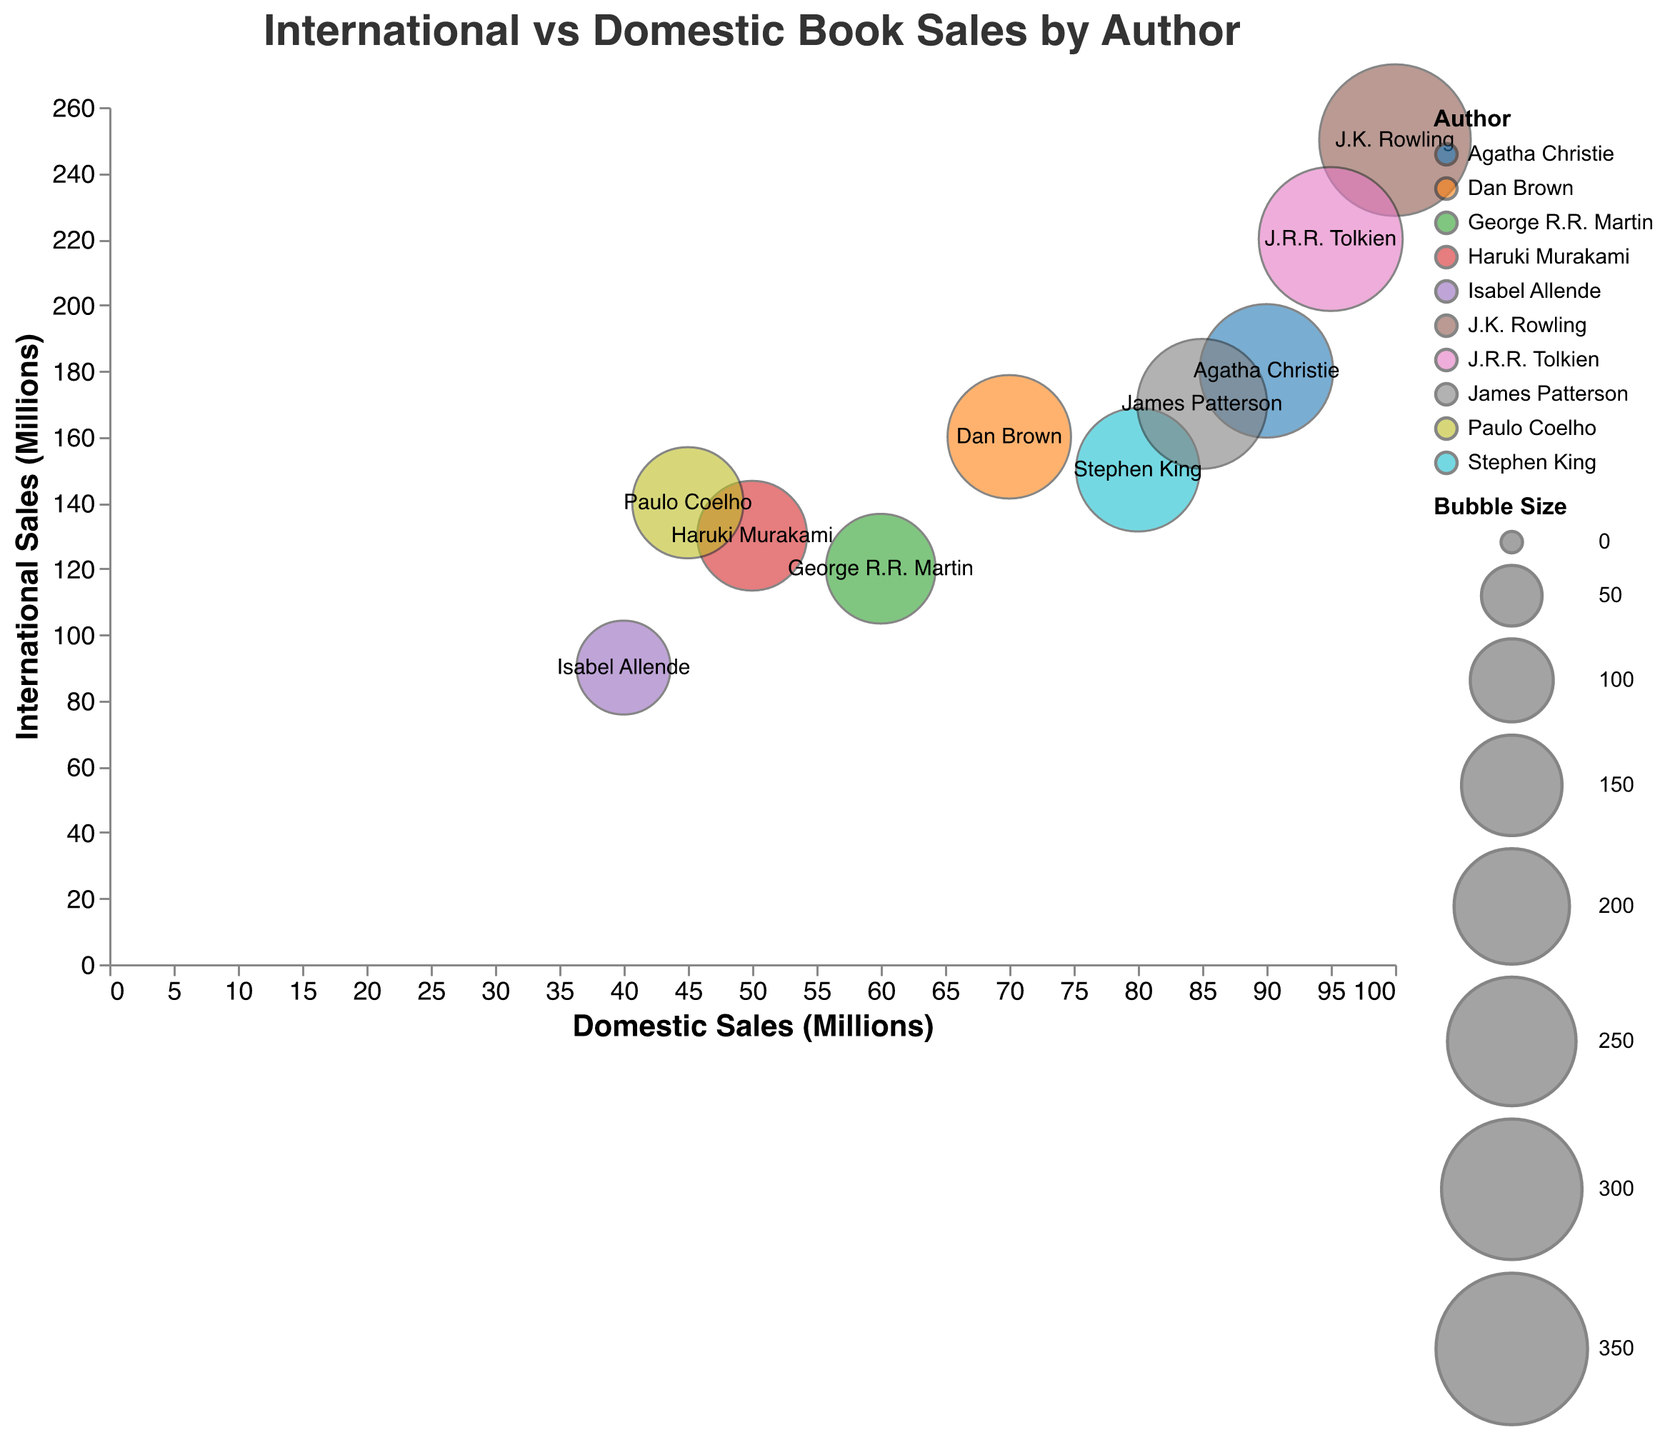Which author has the highest domestic sales? By observing the x-axis, which represents domestic sales, look for the author with the bubble positioned furthest along this axis. This is J.K. Rowling with 100 million domestic sales.
Answer: J.K. Rowling How many authors have total sales over 250 million? By using the tooltips, which show total sales when hovered over, find the authors with total sales numbers exceeding 250 million. These authors are J.K. Rowling, Agatha Christie, and J.R.R. Tolkien.
Answer: 3 What is the range of domestic sales among the authors? To determine the range, find the smallest and largest domestic sales values on the x-axis. The smallest value is from Isabel Allende with 40 million, and the largest value is from J.K. Rowling with 100 million. The range is 100 - 40 = 60 million.
Answer: 60 million Which author has the smallest bubble size? By comparing the size of the bubbles, Isabel Allende's bubble is the smallest with a size of 130.
Answer: Isabel Allende Who has the closest total sales between Paulo Coelho and Haruki Murakami? Using the tooltips, observe the total sales numbers for both authors. Paulo Coelho has 185 million, and Haruki Murakami has 180 million. The difference is 185 - 180 = 5 million. Therefore, Paulo Coelho has slightly higher total sales, closer to Haruki Murakami.
Answer: Paulo Coelho Which author has a higher ratio of international to domestic sales, James Patterson or Stephen King? Calculate the ratio of international to domestic sales for both authors. James Patterson's ratio is 170/85 = 2. Stephen King's ratio is 150/80 = 1.875. James Patterson has a higher ratio.
Answer: James Patterson What can be inferred about the relationship between bubble size and total sales for George R.R. Martin? The tooltip shows that the bubble size corresponds to total sales for each author. For George R.R. Martin, the bubble size is 180, matching his total sales. Hence, bubble size represents total sales directly.
Answer: Bubble size equals total sales How do the domestic sales of J.R.R. Tolkien compare to Agatha Christie? By looking at the x-axis positions of their bubbles, J.R.R. Tolkien is slightly ahead with 95 million compared to Agatha Christie's 90 million in domestic sales, making Tolkien's slightly higher.
Answer: J.R.R. Tolkien Who has more international sales, Dan Brown or Stephen King? Refer to the y-axis, Dan Brown’s position at 160 million international sales, while Stephen King is at 150 million. Dan Brown has higher international sales.
Answer: Dan Brown 